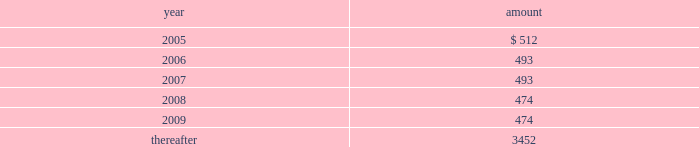Commitments and contingencies rental expense related to office , warehouse space and real estate amounted to $ 608 , $ 324 , and $ 281 for the years ended december 25 , 2004 , december 27 , 2003 , and december 28 , 2002 , respectively .
Future minimum lease payments are as follows : at december 25 , 2004 , the company expects future costs of approximately $ 900 for the completion of its facility expansion in olathe , kansas .
Certain cash balances of gel are held as collateral by a bank securing payment of the united kingdom value-added tax requirements .
These amounted to $ 1457 and $ 1602 at december 25 , 2004 and december 27 , 2003 , respectively , and are reported as restricted cash .
In the normal course of business , the company and its subsidiaries are parties to various legal claims , actions , and complaints , including matters involving patent infringement and other intellectual property claims and various other risks .
It is not possible to predict with certainty whether or not the company and its subsidiaries will ultimately be successful in any of these legal matters , or if not , what the impact might be .
However , the company 2019s management does not expect that the results in any of these legal proceedings will have a material adverse effect on the company 2019s results of operations , financial position or cash flows .
Employee benefit plans gii sponsors an employee retirement plan under which its employees may contribute up to 50% ( 50 % ) of their annual compensation subject to internal revenue code maximum limitations and to which gii contributes a specified percentage of each participant 2019s annual compensation up to certain limits as defined in the plan .
Additionally , gel has a defined contribution plan under which its employees may contribute up to 5% ( 5 % ) of their annual compensation .
Both gii and gel contribute an amount determined annually at the discretion of the board of directors .
During the years ended december 25 , 2004 , december 27 , 2003 , and december 28 , 2002 , expense related to these plans of $ 5183 , $ 4197 , and $ 2728 , respectively , was charged to operations .
Certain of the company 2019s foreign subsidiaries participate in local defined benefit pension plans .
Contributions are calculated by formulas that consider final pensionable salaries .
Neither obligations nor contributions for the years ended december 25 , 2004 , december 27 , 2003 , and december 28 , 2002 were significant. .

What is the percentual increase expense related to these plans during 2002 and 2003? 
Rationale: it is the 2003's expense divided by 2002 one .
Computations: ((4197 / 2728) - 1)
Answer: 0.53849. 